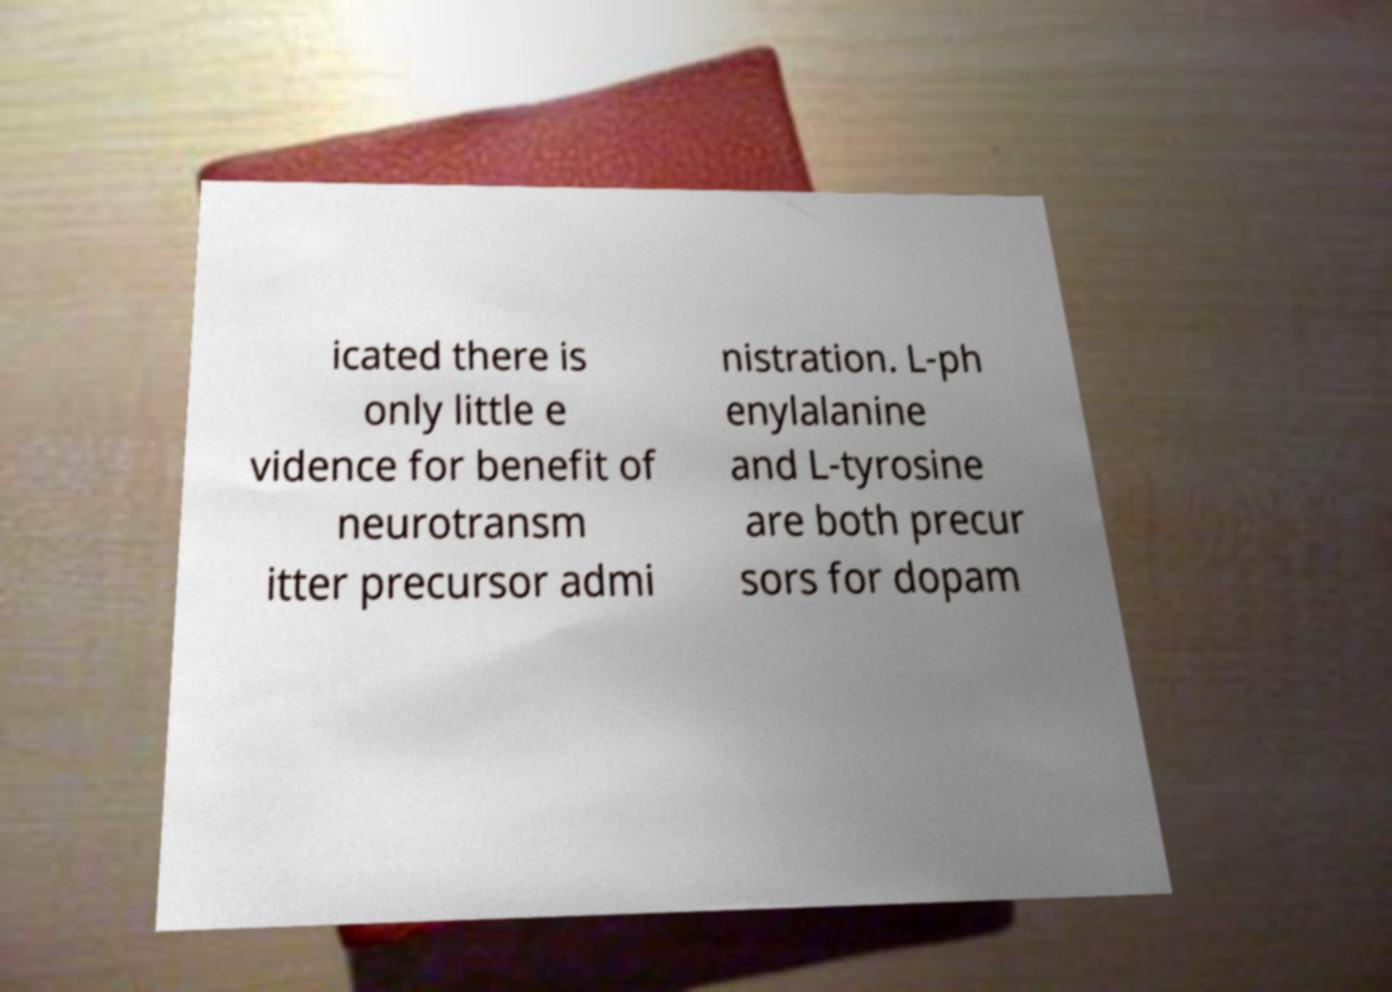Please read and relay the text visible in this image. What does it say? icated there is only little e vidence for benefit of neurotransm itter precursor admi nistration. L-ph enylalanine and L-tyrosine are both precur sors for dopam 